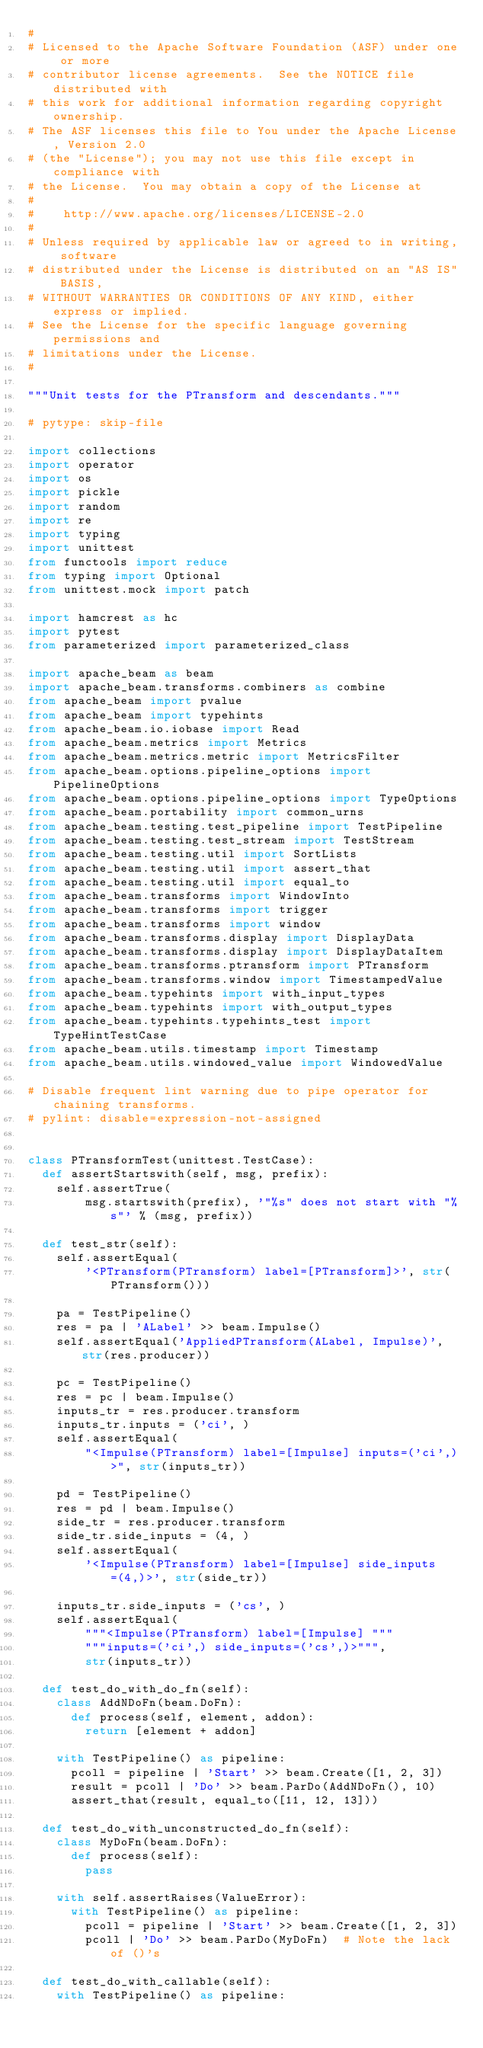<code> <loc_0><loc_0><loc_500><loc_500><_Python_>#
# Licensed to the Apache Software Foundation (ASF) under one or more
# contributor license agreements.  See the NOTICE file distributed with
# this work for additional information regarding copyright ownership.
# The ASF licenses this file to You under the Apache License, Version 2.0
# (the "License"); you may not use this file except in compliance with
# the License.  You may obtain a copy of the License at
#
#    http://www.apache.org/licenses/LICENSE-2.0
#
# Unless required by applicable law or agreed to in writing, software
# distributed under the License is distributed on an "AS IS" BASIS,
# WITHOUT WARRANTIES OR CONDITIONS OF ANY KIND, either express or implied.
# See the License for the specific language governing permissions and
# limitations under the License.
#

"""Unit tests for the PTransform and descendants."""

# pytype: skip-file

import collections
import operator
import os
import pickle
import random
import re
import typing
import unittest
from functools import reduce
from typing import Optional
from unittest.mock import patch

import hamcrest as hc
import pytest
from parameterized import parameterized_class

import apache_beam as beam
import apache_beam.transforms.combiners as combine
from apache_beam import pvalue
from apache_beam import typehints
from apache_beam.io.iobase import Read
from apache_beam.metrics import Metrics
from apache_beam.metrics.metric import MetricsFilter
from apache_beam.options.pipeline_options import PipelineOptions
from apache_beam.options.pipeline_options import TypeOptions
from apache_beam.portability import common_urns
from apache_beam.testing.test_pipeline import TestPipeline
from apache_beam.testing.test_stream import TestStream
from apache_beam.testing.util import SortLists
from apache_beam.testing.util import assert_that
from apache_beam.testing.util import equal_to
from apache_beam.transforms import WindowInto
from apache_beam.transforms import trigger
from apache_beam.transforms import window
from apache_beam.transforms.display import DisplayData
from apache_beam.transforms.display import DisplayDataItem
from apache_beam.transforms.ptransform import PTransform
from apache_beam.transforms.window import TimestampedValue
from apache_beam.typehints import with_input_types
from apache_beam.typehints import with_output_types
from apache_beam.typehints.typehints_test import TypeHintTestCase
from apache_beam.utils.timestamp import Timestamp
from apache_beam.utils.windowed_value import WindowedValue

# Disable frequent lint warning due to pipe operator for chaining transforms.
# pylint: disable=expression-not-assigned


class PTransformTest(unittest.TestCase):
  def assertStartswith(self, msg, prefix):
    self.assertTrue(
        msg.startswith(prefix), '"%s" does not start with "%s"' % (msg, prefix))

  def test_str(self):
    self.assertEqual(
        '<PTransform(PTransform) label=[PTransform]>', str(PTransform()))

    pa = TestPipeline()
    res = pa | 'ALabel' >> beam.Impulse()
    self.assertEqual('AppliedPTransform(ALabel, Impulse)', str(res.producer))

    pc = TestPipeline()
    res = pc | beam.Impulse()
    inputs_tr = res.producer.transform
    inputs_tr.inputs = ('ci', )
    self.assertEqual(
        "<Impulse(PTransform) label=[Impulse] inputs=('ci',)>", str(inputs_tr))

    pd = TestPipeline()
    res = pd | beam.Impulse()
    side_tr = res.producer.transform
    side_tr.side_inputs = (4, )
    self.assertEqual(
        '<Impulse(PTransform) label=[Impulse] side_inputs=(4,)>', str(side_tr))

    inputs_tr.side_inputs = ('cs', )
    self.assertEqual(
        """<Impulse(PTransform) label=[Impulse] """
        """inputs=('ci',) side_inputs=('cs',)>""",
        str(inputs_tr))

  def test_do_with_do_fn(self):
    class AddNDoFn(beam.DoFn):
      def process(self, element, addon):
        return [element + addon]

    with TestPipeline() as pipeline:
      pcoll = pipeline | 'Start' >> beam.Create([1, 2, 3])
      result = pcoll | 'Do' >> beam.ParDo(AddNDoFn(), 10)
      assert_that(result, equal_to([11, 12, 13]))

  def test_do_with_unconstructed_do_fn(self):
    class MyDoFn(beam.DoFn):
      def process(self):
        pass

    with self.assertRaises(ValueError):
      with TestPipeline() as pipeline:
        pcoll = pipeline | 'Start' >> beam.Create([1, 2, 3])
        pcoll | 'Do' >> beam.ParDo(MyDoFn)  # Note the lack of ()'s

  def test_do_with_callable(self):
    with TestPipeline() as pipeline:</code> 